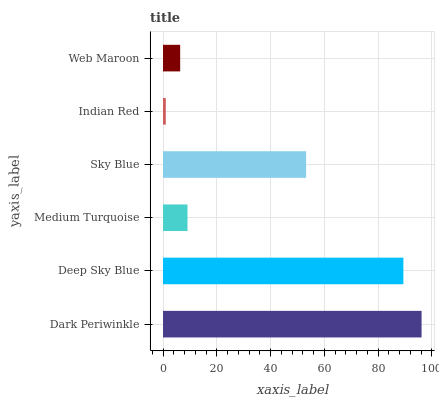Is Indian Red the minimum?
Answer yes or no. Yes. Is Dark Periwinkle the maximum?
Answer yes or no. Yes. Is Deep Sky Blue the minimum?
Answer yes or no. No. Is Deep Sky Blue the maximum?
Answer yes or no. No. Is Dark Periwinkle greater than Deep Sky Blue?
Answer yes or no. Yes. Is Deep Sky Blue less than Dark Periwinkle?
Answer yes or no. Yes. Is Deep Sky Blue greater than Dark Periwinkle?
Answer yes or no. No. Is Dark Periwinkle less than Deep Sky Blue?
Answer yes or no. No. Is Sky Blue the high median?
Answer yes or no. Yes. Is Medium Turquoise the low median?
Answer yes or no. Yes. Is Web Maroon the high median?
Answer yes or no. No. Is Indian Red the low median?
Answer yes or no. No. 